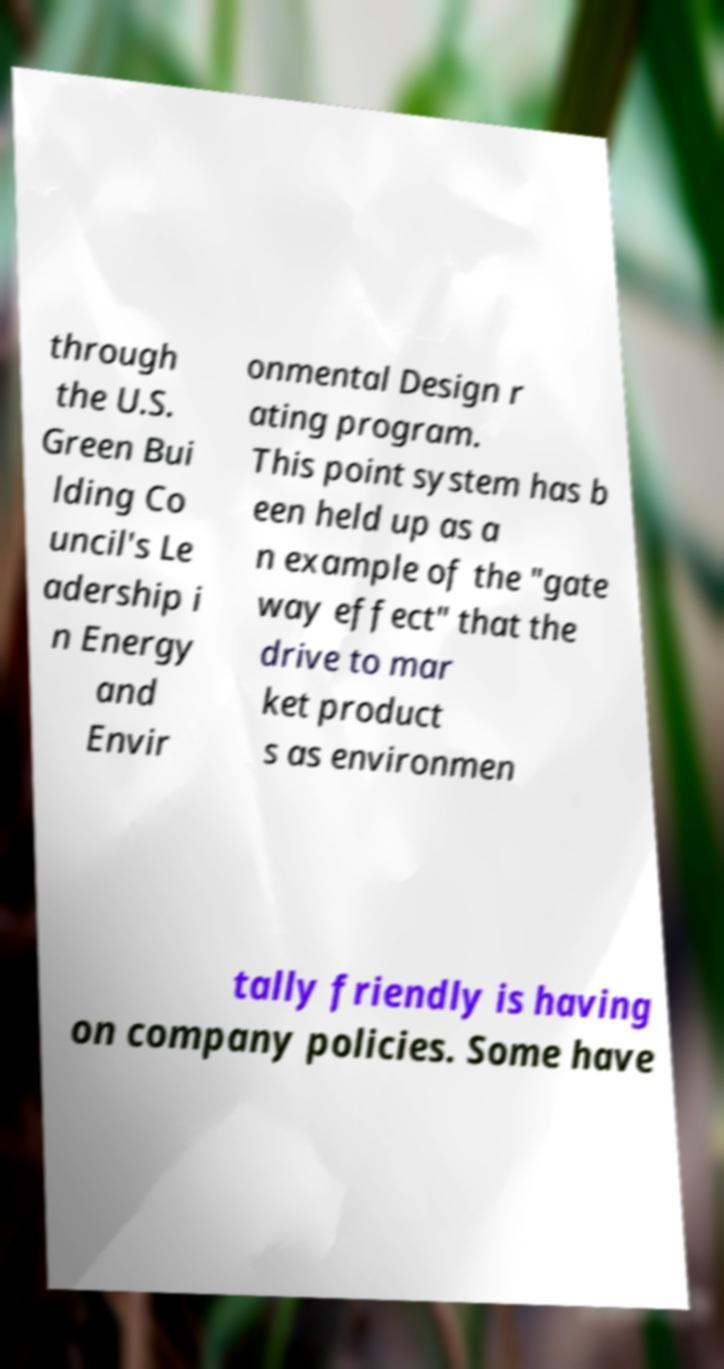Can you accurately transcribe the text from the provided image for me? through the U.S. Green Bui lding Co uncil's Le adership i n Energy and Envir onmental Design r ating program. This point system has b een held up as a n example of the "gate way effect" that the drive to mar ket product s as environmen tally friendly is having on company policies. Some have 